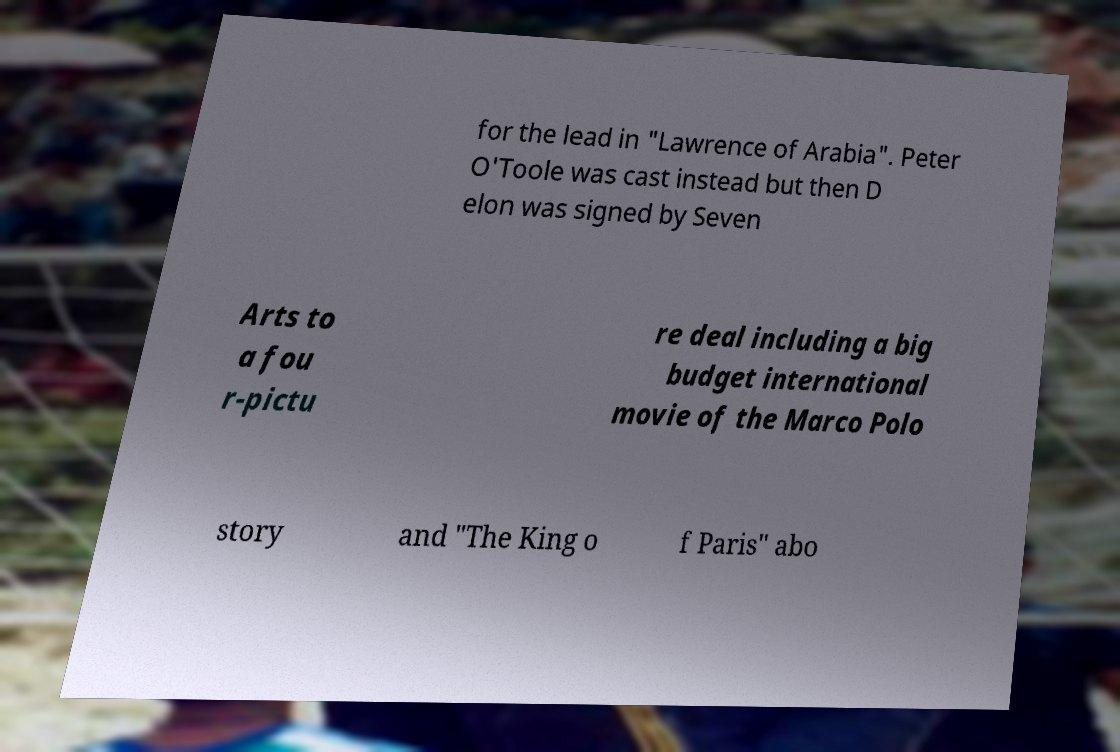There's text embedded in this image that I need extracted. Can you transcribe it verbatim? for the lead in "Lawrence of Arabia". Peter O'Toole was cast instead but then D elon was signed by Seven Arts to a fou r-pictu re deal including a big budget international movie of the Marco Polo story and "The King o f Paris" abo 